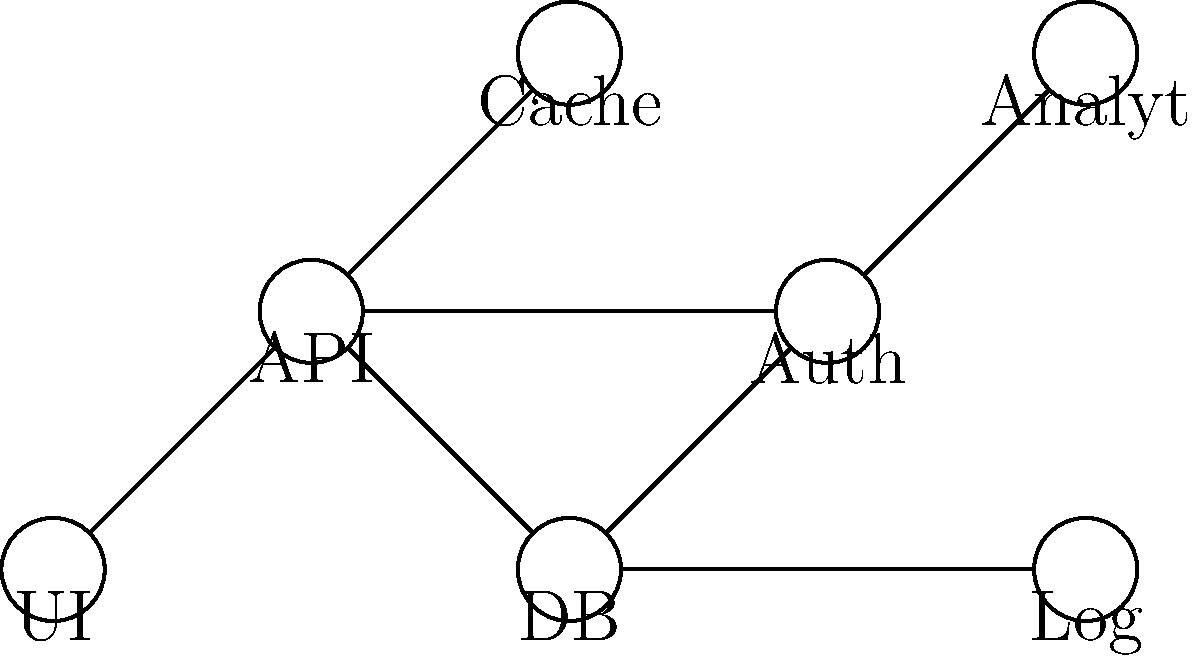In the network diagram representing a software project's components, what is the minimum number of other components that must be traversed to get from the UI to the Analytics module? To determine the minimum number of components that must be traversed from UI to Analytics, we need to follow these steps:

1. Identify the starting point (UI) and the endpoint (Analytics, labeled as "Analyt" in the diagram).
2. Trace all possible paths from UI to Analytics.
3. Count the number of intermediate components for each path.
4. Select the path with the minimum number of intermediate components.

Tracing the paths:

Path 1: UI → API → DB → Analytics
- Intermediate components: API, DB
- Total components traversed: 2

There are no other valid paths from UI to Analytics.

Therefore, the minimum number of components that must be traversed is 2.
Answer: 2 